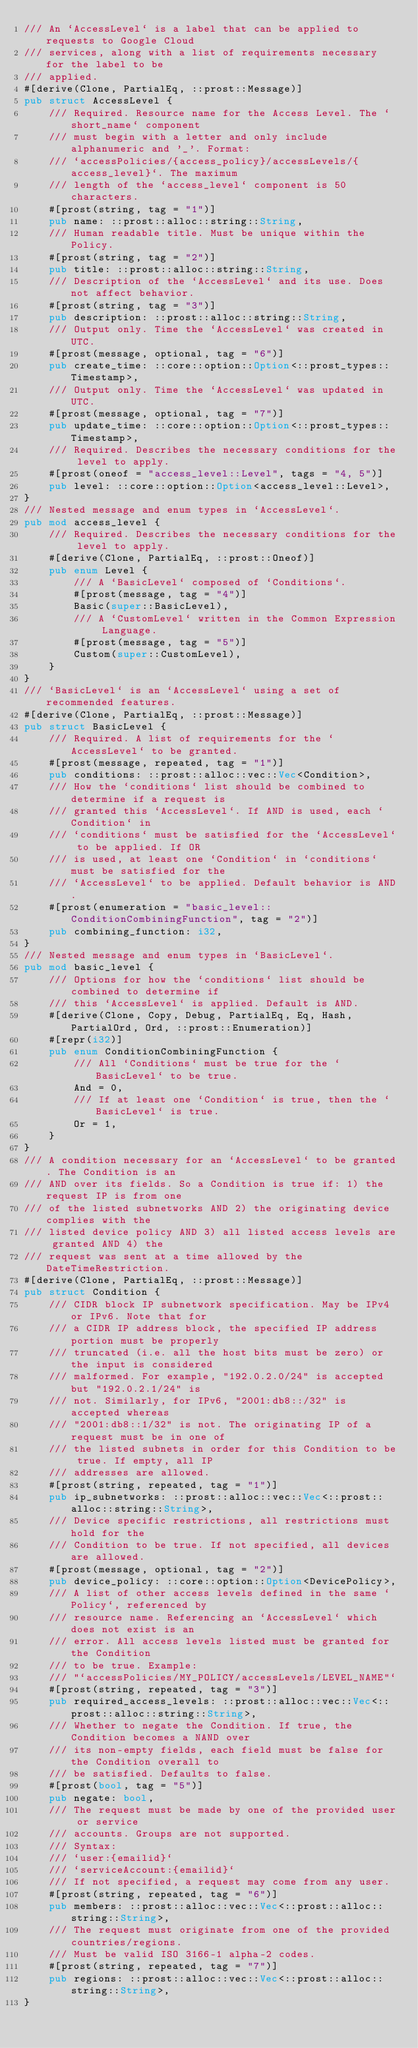Convert code to text. <code><loc_0><loc_0><loc_500><loc_500><_Rust_>/// An `AccessLevel` is a label that can be applied to requests to Google Cloud
/// services, along with a list of requirements necessary for the label to be
/// applied.
#[derive(Clone, PartialEq, ::prost::Message)]
pub struct AccessLevel {
    /// Required. Resource name for the Access Level. The `short_name` component
    /// must begin with a letter and only include alphanumeric and '_'. Format:
    /// `accessPolicies/{access_policy}/accessLevels/{access_level}`. The maximum
    /// length of the `access_level` component is 50 characters.
    #[prost(string, tag = "1")]
    pub name: ::prost::alloc::string::String,
    /// Human readable title. Must be unique within the Policy.
    #[prost(string, tag = "2")]
    pub title: ::prost::alloc::string::String,
    /// Description of the `AccessLevel` and its use. Does not affect behavior.
    #[prost(string, tag = "3")]
    pub description: ::prost::alloc::string::String,
    /// Output only. Time the `AccessLevel` was created in UTC.
    #[prost(message, optional, tag = "6")]
    pub create_time: ::core::option::Option<::prost_types::Timestamp>,
    /// Output only. Time the `AccessLevel` was updated in UTC.
    #[prost(message, optional, tag = "7")]
    pub update_time: ::core::option::Option<::prost_types::Timestamp>,
    /// Required. Describes the necessary conditions for the level to apply.
    #[prost(oneof = "access_level::Level", tags = "4, 5")]
    pub level: ::core::option::Option<access_level::Level>,
}
/// Nested message and enum types in `AccessLevel`.
pub mod access_level {
    /// Required. Describes the necessary conditions for the level to apply.
    #[derive(Clone, PartialEq, ::prost::Oneof)]
    pub enum Level {
        /// A `BasicLevel` composed of `Conditions`.
        #[prost(message, tag = "4")]
        Basic(super::BasicLevel),
        /// A `CustomLevel` written in the Common Expression Language.
        #[prost(message, tag = "5")]
        Custom(super::CustomLevel),
    }
}
/// `BasicLevel` is an `AccessLevel` using a set of recommended features.
#[derive(Clone, PartialEq, ::prost::Message)]
pub struct BasicLevel {
    /// Required. A list of requirements for the `AccessLevel` to be granted.
    #[prost(message, repeated, tag = "1")]
    pub conditions: ::prost::alloc::vec::Vec<Condition>,
    /// How the `conditions` list should be combined to determine if a request is
    /// granted this `AccessLevel`. If AND is used, each `Condition` in
    /// `conditions` must be satisfied for the `AccessLevel` to be applied. If OR
    /// is used, at least one `Condition` in `conditions` must be satisfied for the
    /// `AccessLevel` to be applied. Default behavior is AND.
    #[prost(enumeration = "basic_level::ConditionCombiningFunction", tag = "2")]
    pub combining_function: i32,
}
/// Nested message and enum types in `BasicLevel`.
pub mod basic_level {
    /// Options for how the `conditions` list should be combined to determine if
    /// this `AccessLevel` is applied. Default is AND.
    #[derive(Clone, Copy, Debug, PartialEq, Eq, Hash, PartialOrd, Ord, ::prost::Enumeration)]
    #[repr(i32)]
    pub enum ConditionCombiningFunction {
        /// All `Conditions` must be true for the `BasicLevel` to be true.
        And = 0,
        /// If at least one `Condition` is true, then the `BasicLevel` is true.
        Or = 1,
    }
}
/// A condition necessary for an `AccessLevel` to be granted. The Condition is an
/// AND over its fields. So a Condition is true if: 1) the request IP is from one
/// of the listed subnetworks AND 2) the originating device complies with the
/// listed device policy AND 3) all listed access levels are granted AND 4) the
/// request was sent at a time allowed by the DateTimeRestriction.
#[derive(Clone, PartialEq, ::prost::Message)]
pub struct Condition {
    /// CIDR block IP subnetwork specification. May be IPv4 or IPv6. Note that for
    /// a CIDR IP address block, the specified IP address portion must be properly
    /// truncated (i.e. all the host bits must be zero) or the input is considered
    /// malformed. For example, "192.0.2.0/24" is accepted but "192.0.2.1/24" is
    /// not. Similarly, for IPv6, "2001:db8::/32" is accepted whereas
    /// "2001:db8::1/32" is not. The originating IP of a request must be in one of
    /// the listed subnets in order for this Condition to be true. If empty, all IP
    /// addresses are allowed.
    #[prost(string, repeated, tag = "1")]
    pub ip_subnetworks: ::prost::alloc::vec::Vec<::prost::alloc::string::String>,
    /// Device specific restrictions, all restrictions must hold for the
    /// Condition to be true. If not specified, all devices are allowed.
    #[prost(message, optional, tag = "2")]
    pub device_policy: ::core::option::Option<DevicePolicy>,
    /// A list of other access levels defined in the same `Policy`, referenced by
    /// resource name. Referencing an `AccessLevel` which does not exist is an
    /// error. All access levels listed must be granted for the Condition
    /// to be true. Example:
    /// "`accessPolicies/MY_POLICY/accessLevels/LEVEL_NAME"`
    #[prost(string, repeated, tag = "3")]
    pub required_access_levels: ::prost::alloc::vec::Vec<::prost::alloc::string::String>,
    /// Whether to negate the Condition. If true, the Condition becomes a NAND over
    /// its non-empty fields, each field must be false for the Condition overall to
    /// be satisfied. Defaults to false.
    #[prost(bool, tag = "5")]
    pub negate: bool,
    /// The request must be made by one of the provided user or service
    /// accounts. Groups are not supported.
    /// Syntax:
    /// `user:{emailid}`
    /// `serviceAccount:{emailid}`
    /// If not specified, a request may come from any user.
    #[prost(string, repeated, tag = "6")]
    pub members: ::prost::alloc::vec::Vec<::prost::alloc::string::String>,
    /// The request must originate from one of the provided countries/regions.
    /// Must be valid ISO 3166-1 alpha-2 codes.
    #[prost(string, repeated, tag = "7")]
    pub regions: ::prost::alloc::vec::Vec<::prost::alloc::string::String>,
}</code> 